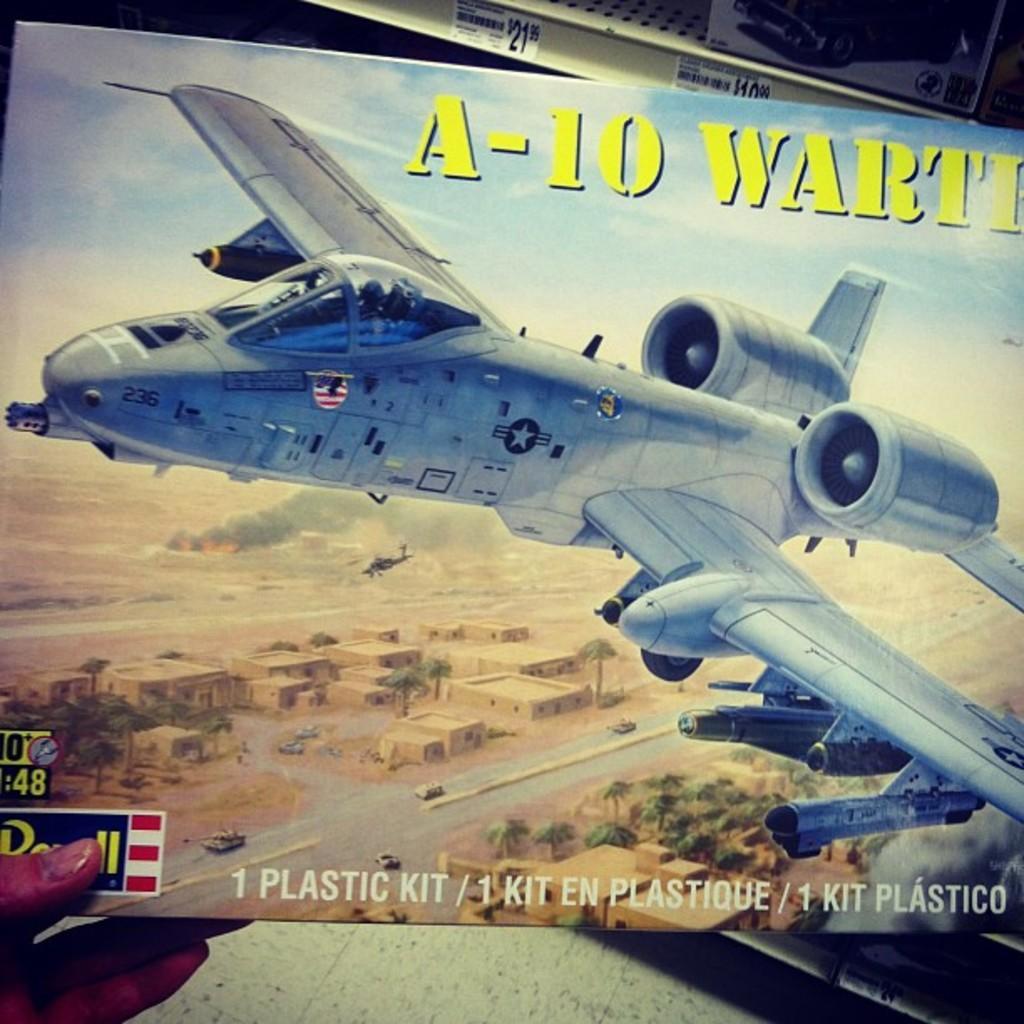Describe this image in one or two sentences. In the foreground of this picture we can see the hand of a person holding a poster on which we can see the picture of an aircraft flying in the sky and we can see the picture of buildings, trees, vehicles, ground and some other items. At the bottom of the poster there is a text. In the background there are some objects. 